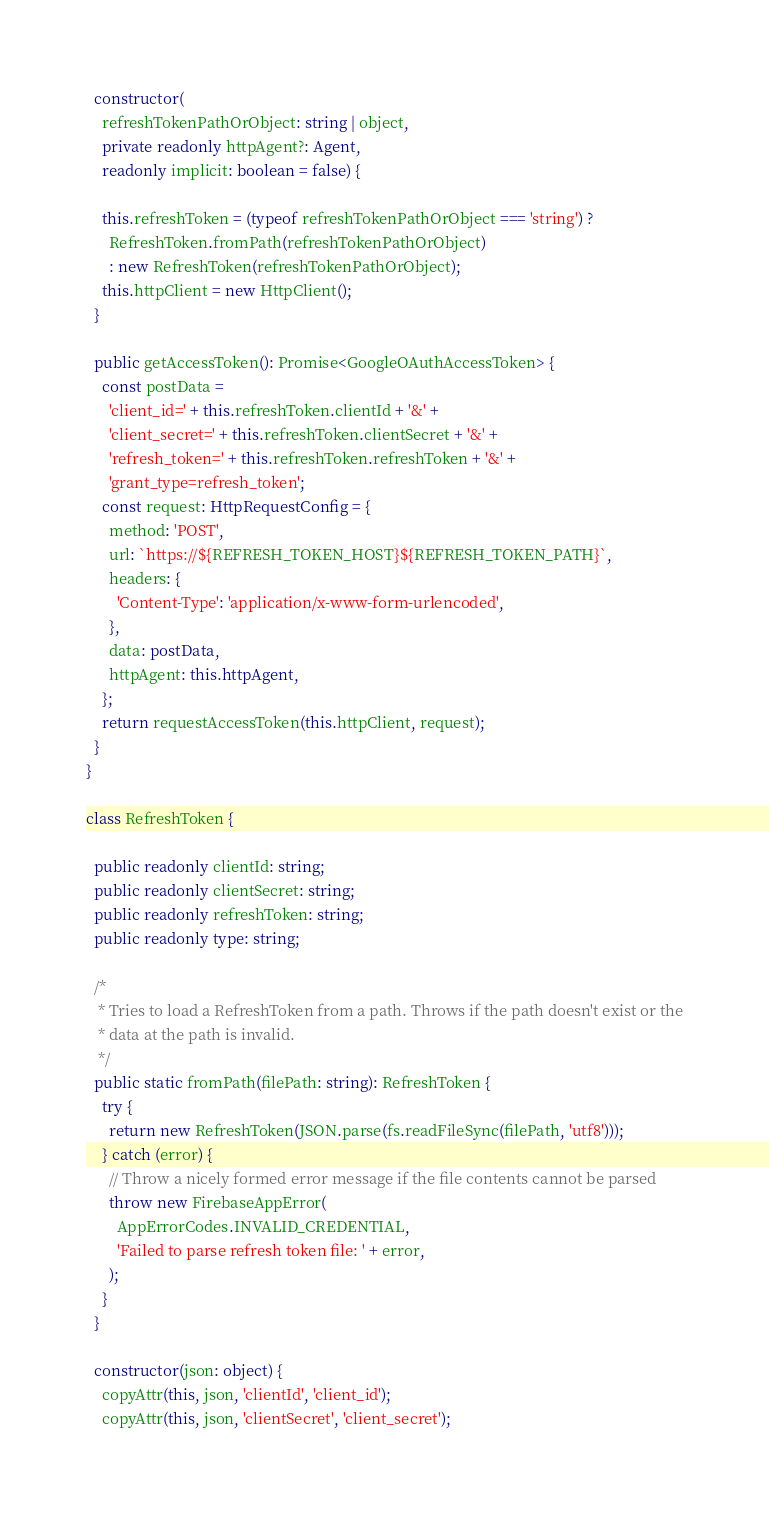<code> <loc_0><loc_0><loc_500><loc_500><_TypeScript_>  constructor(
    refreshTokenPathOrObject: string | object,
    private readonly httpAgent?: Agent,
    readonly implicit: boolean = false) {

    this.refreshToken = (typeof refreshTokenPathOrObject === 'string') ?
      RefreshToken.fromPath(refreshTokenPathOrObject)
      : new RefreshToken(refreshTokenPathOrObject);
    this.httpClient = new HttpClient();
  }

  public getAccessToken(): Promise<GoogleOAuthAccessToken> {
    const postData =
      'client_id=' + this.refreshToken.clientId + '&' +
      'client_secret=' + this.refreshToken.clientSecret + '&' +
      'refresh_token=' + this.refreshToken.refreshToken + '&' +
      'grant_type=refresh_token';
    const request: HttpRequestConfig = {
      method: 'POST',
      url: `https://${REFRESH_TOKEN_HOST}${REFRESH_TOKEN_PATH}`,
      headers: {
        'Content-Type': 'application/x-www-form-urlencoded',
      },
      data: postData,
      httpAgent: this.httpAgent,
    };
    return requestAccessToken(this.httpClient, request);
  }
}

class RefreshToken {

  public readonly clientId: string;
  public readonly clientSecret: string;
  public readonly refreshToken: string;
  public readonly type: string;

  /*
   * Tries to load a RefreshToken from a path. Throws if the path doesn't exist or the
   * data at the path is invalid.
   */
  public static fromPath(filePath: string): RefreshToken {
    try {
      return new RefreshToken(JSON.parse(fs.readFileSync(filePath, 'utf8')));
    } catch (error) {
      // Throw a nicely formed error message if the file contents cannot be parsed
      throw new FirebaseAppError(
        AppErrorCodes.INVALID_CREDENTIAL,
        'Failed to parse refresh token file: ' + error,
      );
    }
  }

  constructor(json: object) {
    copyAttr(this, json, 'clientId', 'client_id');
    copyAttr(this, json, 'clientSecret', 'client_secret');</code> 